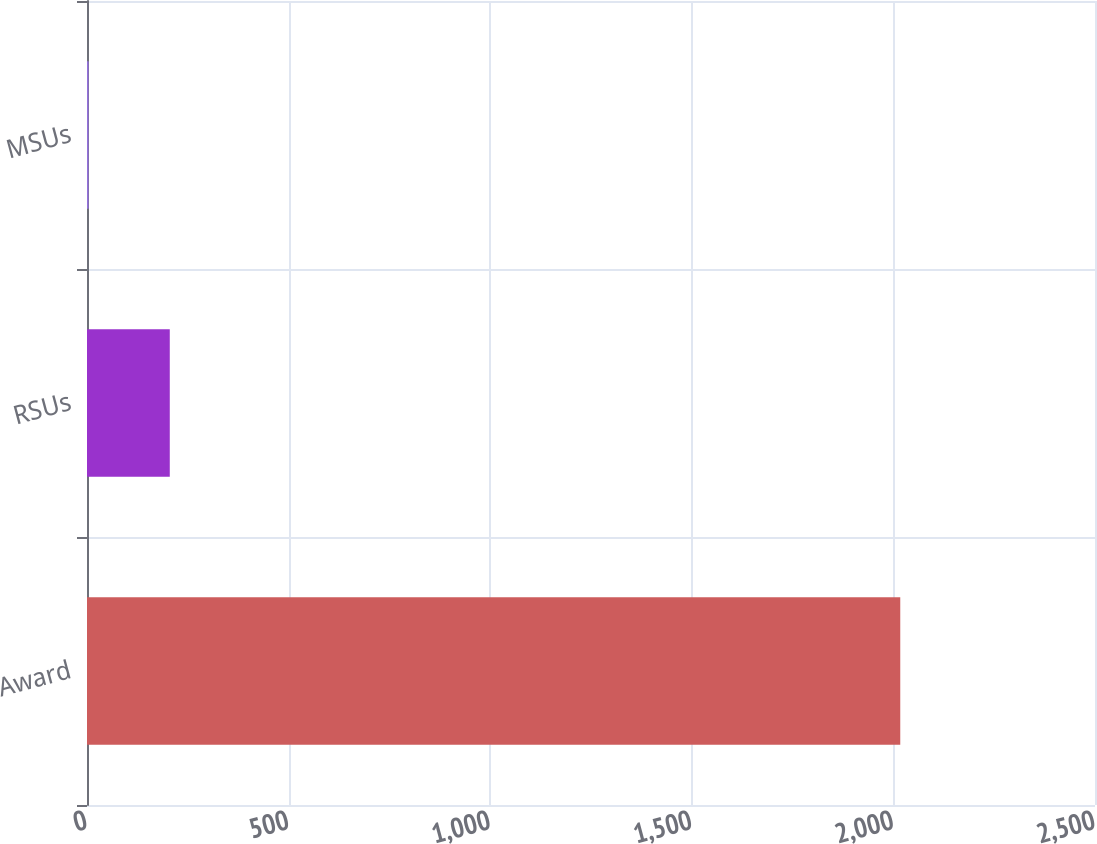<chart> <loc_0><loc_0><loc_500><loc_500><bar_chart><fcel>Award<fcel>RSUs<fcel>MSUs<nl><fcel>2017<fcel>205.3<fcel>4<nl></chart> 